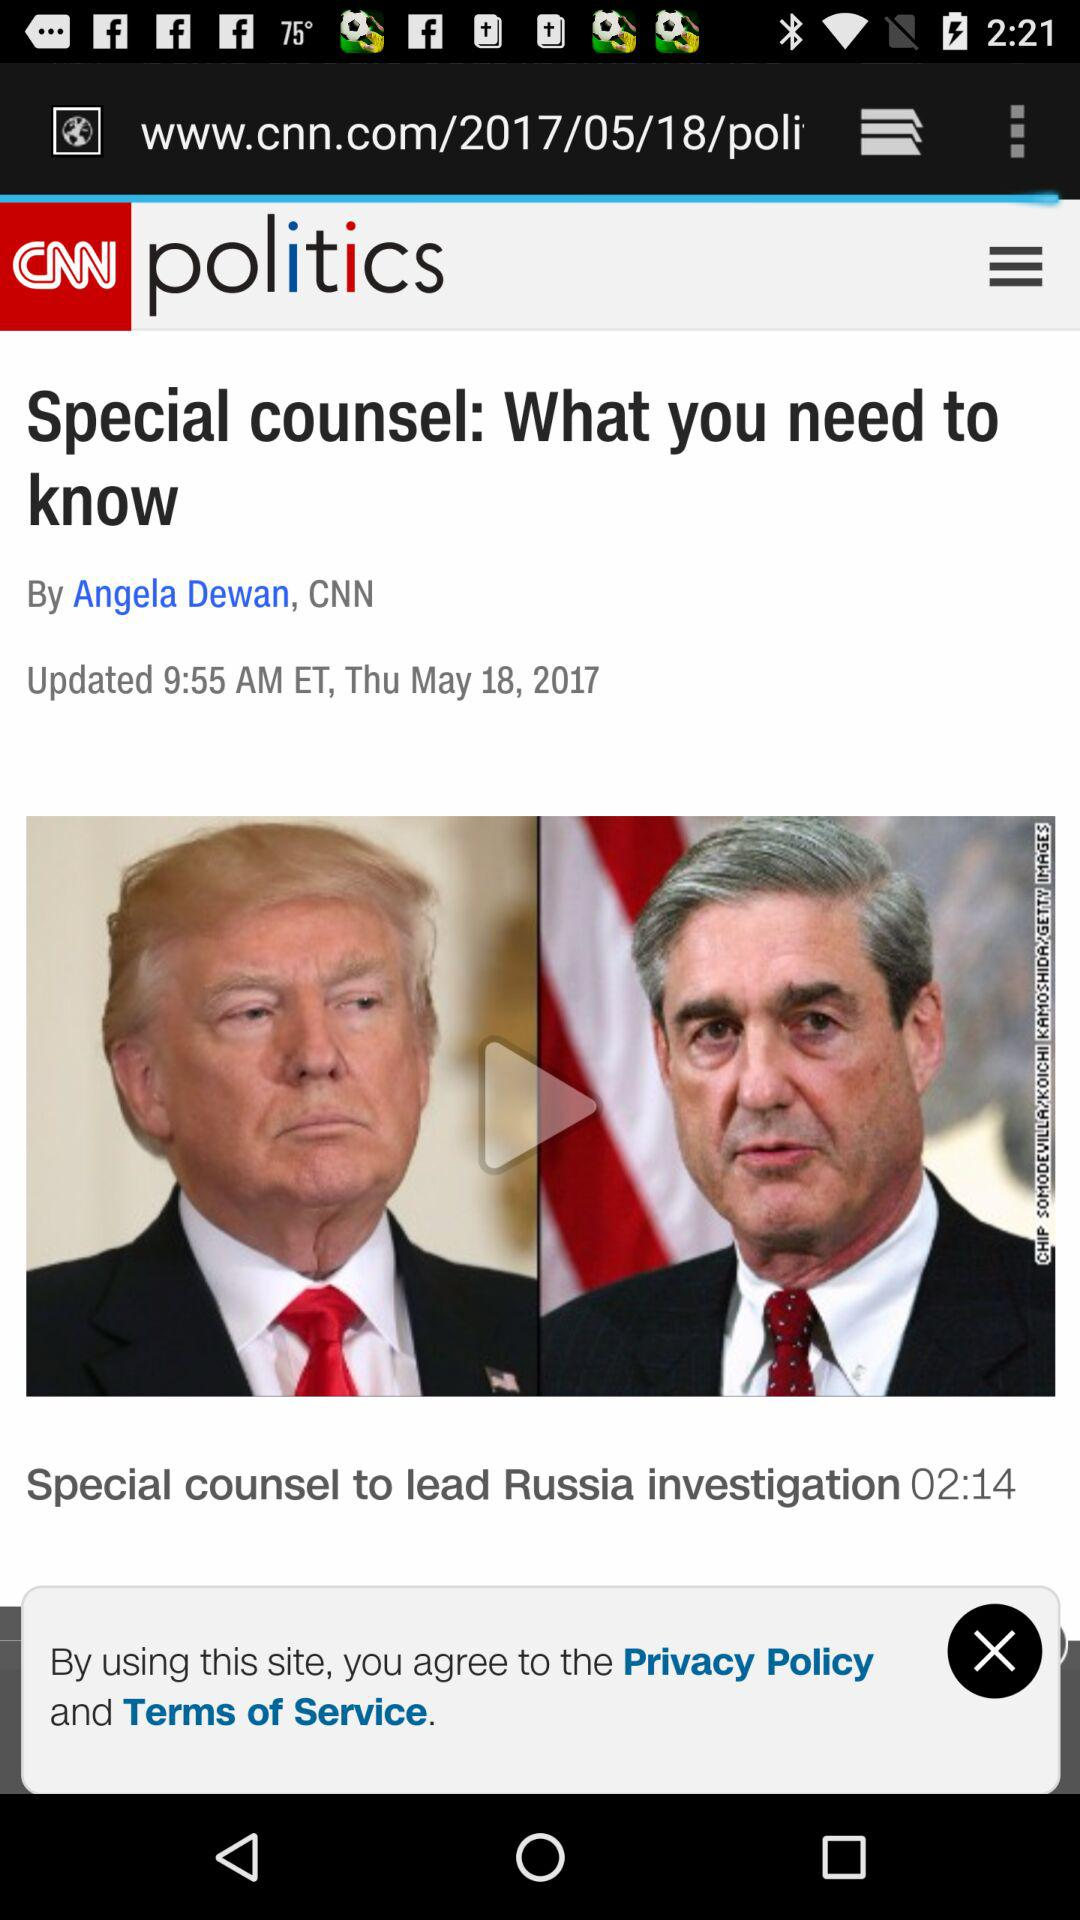What is the name of the author? The name of the author is Angela Dewan. 